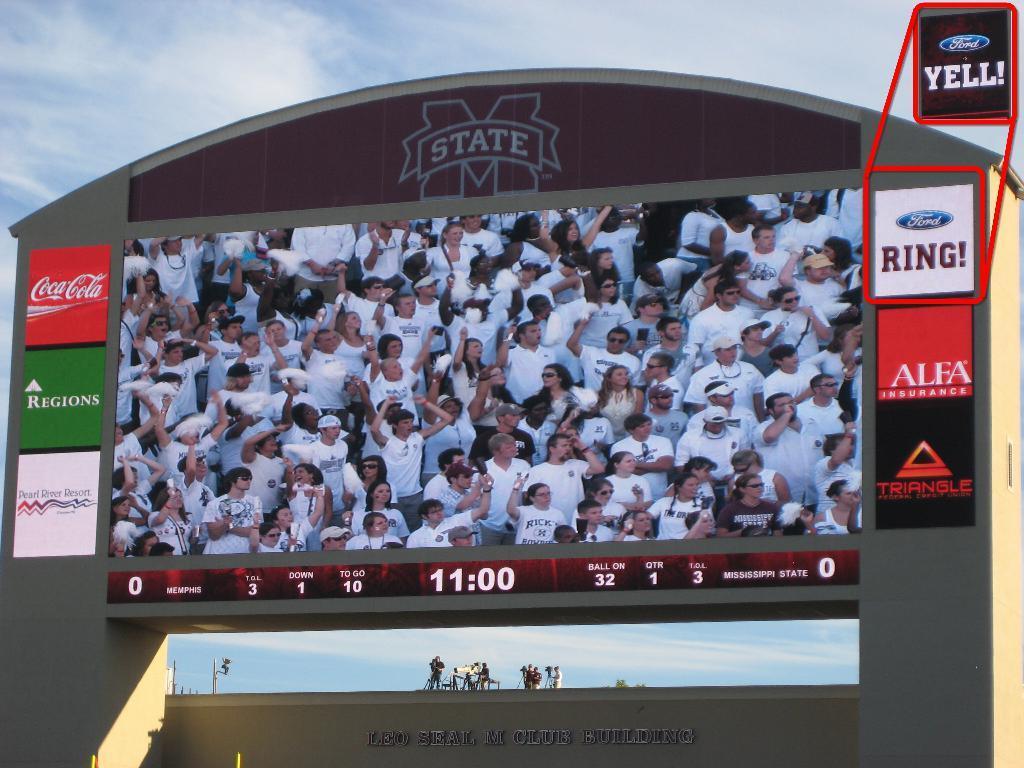Can you describe this image briefly? In this image I can see the screen. I can see some boards attached to the screen. In the screen there are group of people with white color dresses. In the background I can see few people, clouds and the sky. 